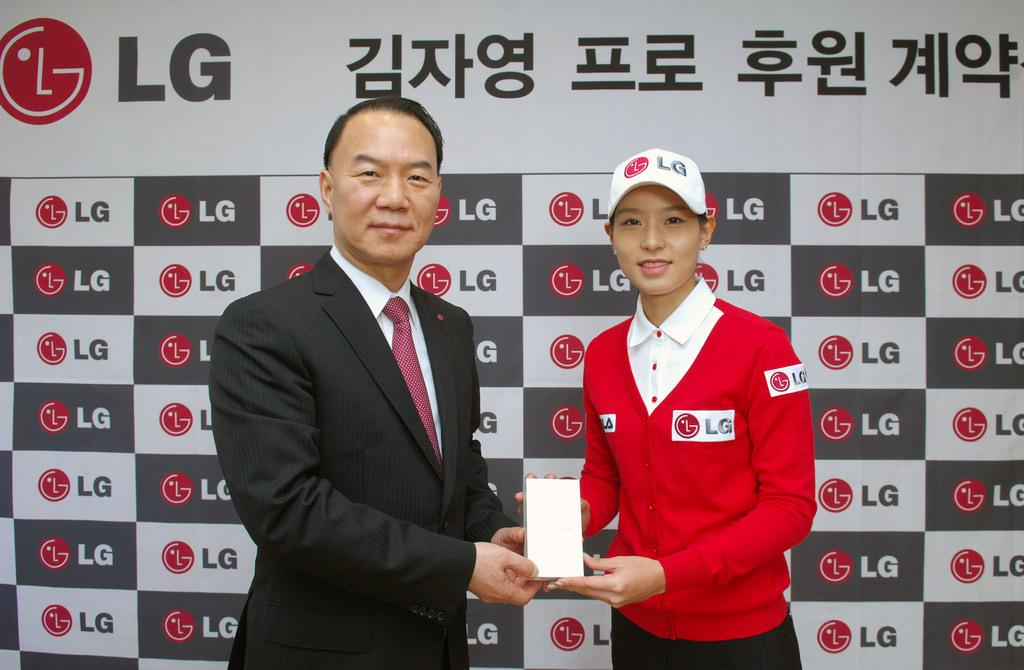How many people are in the image? There are two persons in the image. What are the two persons doing in the image? The two persons are holding an object. What can be seen in the background of the image? There is a banner in the background of the image. What type of rose can be seen growing in the cave in the image? There is no cave or rose present in the image. 